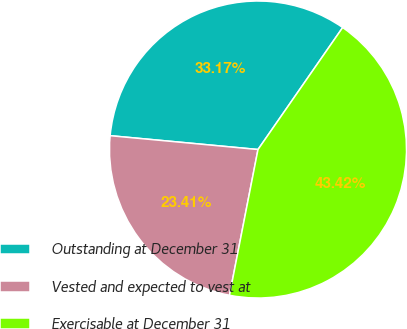Convert chart. <chart><loc_0><loc_0><loc_500><loc_500><pie_chart><fcel>Outstanding at December 31<fcel>Vested and expected to vest at<fcel>Exercisable at December 31<nl><fcel>33.17%<fcel>23.41%<fcel>43.42%<nl></chart> 